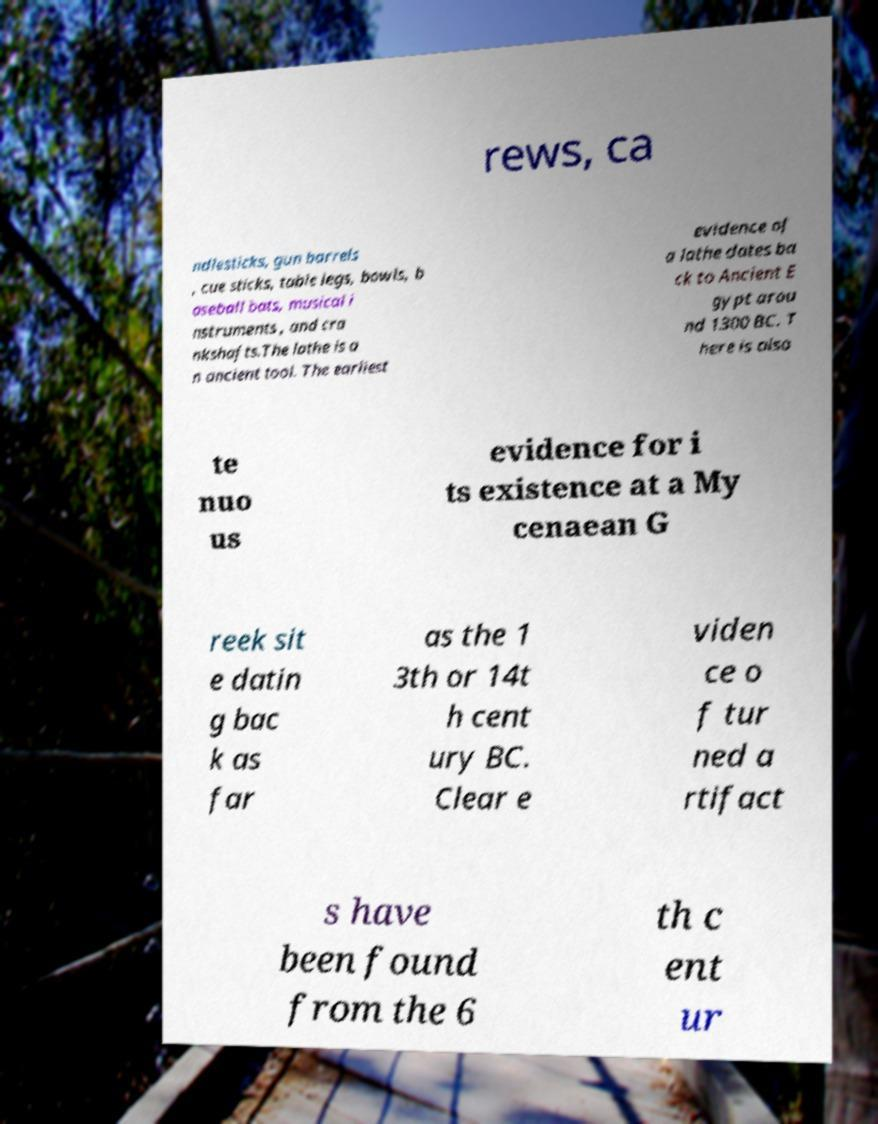There's text embedded in this image that I need extracted. Can you transcribe it verbatim? rews, ca ndlesticks, gun barrels , cue sticks, table legs, bowls, b aseball bats, musical i nstruments , and cra nkshafts.The lathe is a n ancient tool. The earliest evidence of a lathe dates ba ck to Ancient E gypt arou nd 1300 BC. T here is also te nuo us evidence for i ts existence at a My cenaean G reek sit e datin g bac k as far as the 1 3th or 14t h cent ury BC. Clear e viden ce o f tur ned a rtifact s have been found from the 6 th c ent ur 